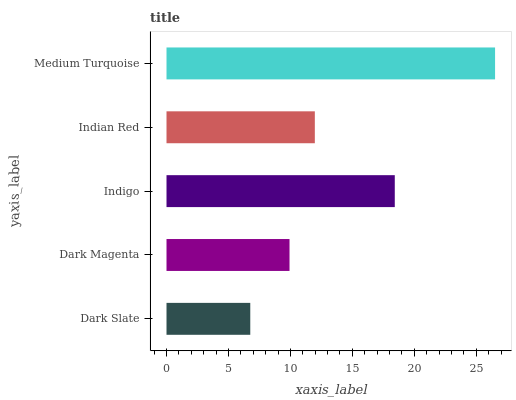Is Dark Slate the minimum?
Answer yes or no. Yes. Is Medium Turquoise the maximum?
Answer yes or no. Yes. Is Dark Magenta the minimum?
Answer yes or no. No. Is Dark Magenta the maximum?
Answer yes or no. No. Is Dark Magenta greater than Dark Slate?
Answer yes or no. Yes. Is Dark Slate less than Dark Magenta?
Answer yes or no. Yes. Is Dark Slate greater than Dark Magenta?
Answer yes or no. No. Is Dark Magenta less than Dark Slate?
Answer yes or no. No. Is Indian Red the high median?
Answer yes or no. Yes. Is Indian Red the low median?
Answer yes or no. Yes. Is Indigo the high median?
Answer yes or no. No. Is Dark Magenta the low median?
Answer yes or no. No. 